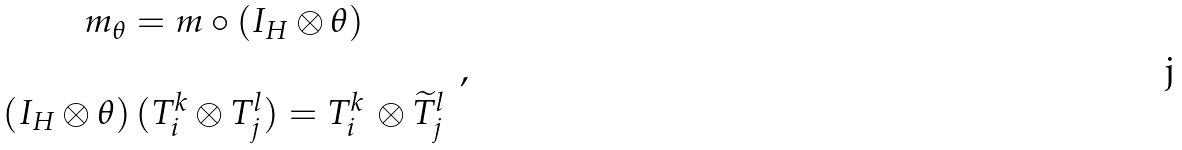Convert formula to latex. <formula><loc_0><loc_0><loc_500><loc_500>\begin{array} { c } m _ { \theta } = m \circ ( I _ { H } \otimes \theta ) \\ \\ ( I _ { H } \otimes \theta ) \, ( T _ { i } ^ { k } \otimes T _ { j } ^ { l } ) = T _ { i } ^ { k } \, \otimes \widetilde { T } _ { j } ^ { l } \end{array} \, ,</formula> 